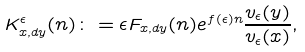Convert formula to latex. <formula><loc_0><loc_0><loc_500><loc_500>K _ { x , d y } ^ { \epsilon } ( n ) \colon = \epsilon F _ { x , d y } ( n ) e ^ { f ( \epsilon ) n } \frac { v _ { \epsilon } ( y ) } { v _ { \epsilon } ( x ) } ,</formula> 